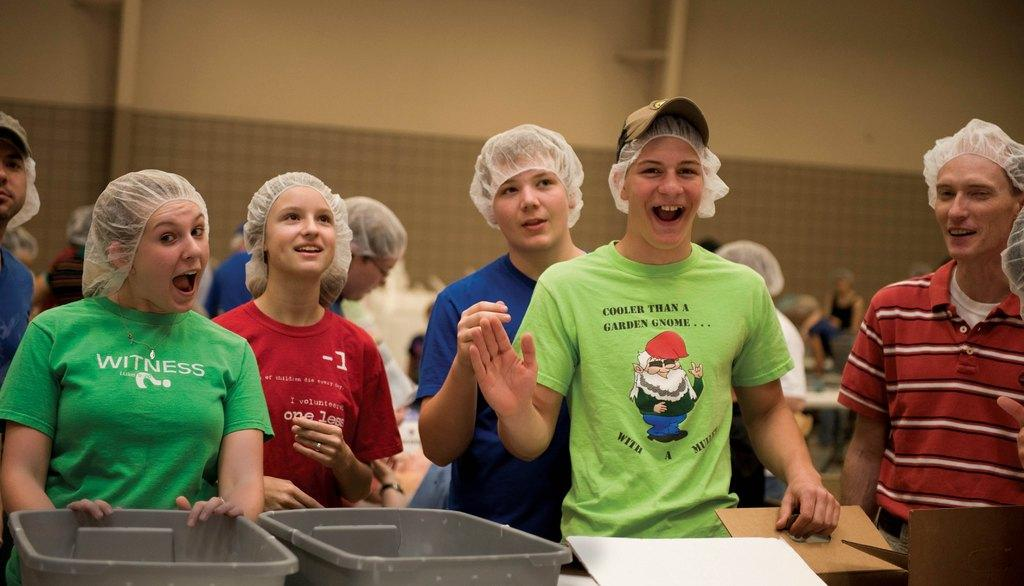What can be seen in the foreground of the picture? There are people, baskets, and desks in the foreground of the picture. How would you describe the background of the image? The background of the image is blurred. What objects or features can be seen in the background of the picture? There are tables, people, and a wall in the background of the picture. What type of sleet can be seen falling from the wall in the background of the image? There is no sleet present in the image, and the wall does not have any falling precipitation. How many yokes are visible on the people in the foreground of the image? There are no yokes visible on the people in the image, as yokes are typically associated with animals or farming equipment and not people. 